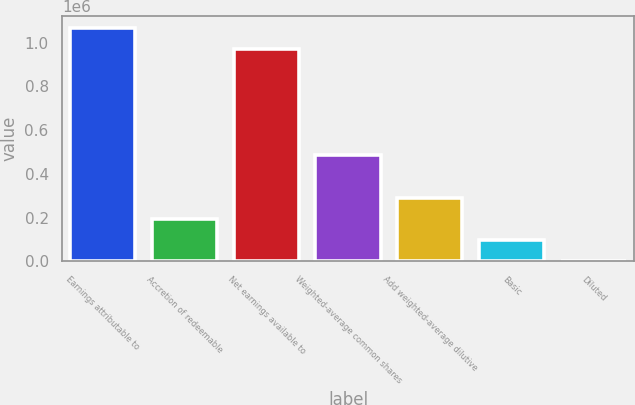<chart> <loc_0><loc_0><loc_500><loc_500><bar_chart><fcel>Earnings attributable to<fcel>Accretion of redeemable<fcel>Net earnings available to<fcel>Weighted-average common shares<fcel>Add weighted-average dilutive<fcel>Basic<fcel>Diluted<nl><fcel>1.06875e+06<fcel>194338<fcel>971592<fcel>485825<fcel>291500<fcel>97175.5<fcel>12.98<nl></chart> 